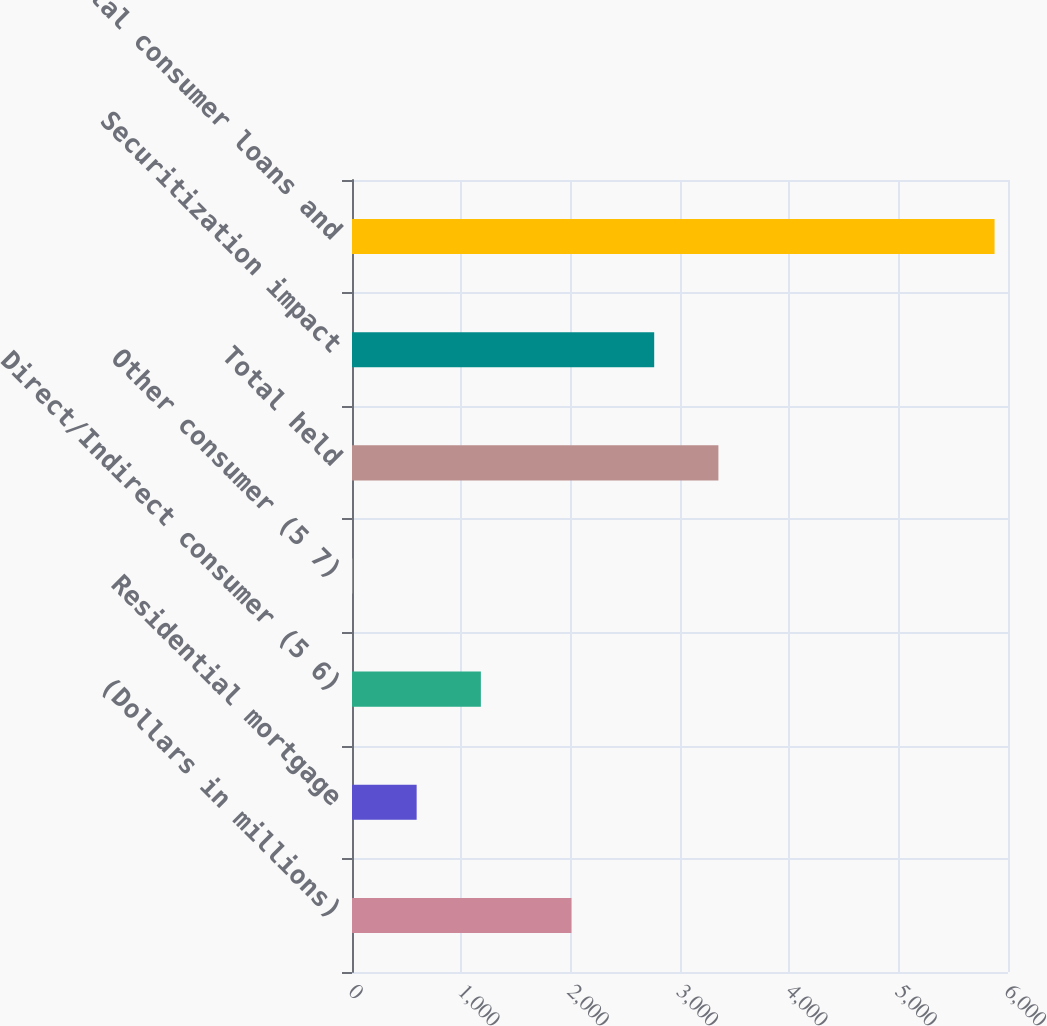Convert chart to OTSL. <chart><loc_0><loc_0><loc_500><loc_500><bar_chart><fcel>(Dollars in millions)<fcel>Residential mortgage<fcel>Direct/Indirect consumer (5 6)<fcel>Other consumer (5 7)<fcel>Total held<fcel>Securitization impact<fcel>Total consumer loans and<nl><fcel>2007<fcel>591.3<fcel>1178.6<fcel>4<fcel>3351.3<fcel>2764<fcel>5877<nl></chart> 